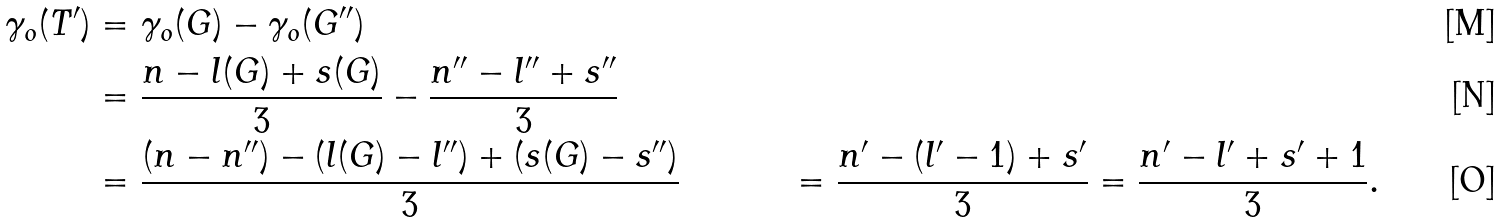Convert formula to latex. <formula><loc_0><loc_0><loc_500><loc_500>\gamma _ { o } ( T ^ { \prime } ) & = \gamma _ { o } ( G ) - \gamma _ { o } ( G ^ { \prime \prime } ) \\ & = \frac { n - l ( G ) + s ( G ) } { 3 } - \frac { n ^ { \prime \prime } - l ^ { \prime \prime } + s ^ { \prime \prime } } { 3 } \\ & = \frac { ( n - n ^ { \prime \prime } ) - ( l ( G ) - l ^ { \prime \prime } ) + ( s ( G ) - s ^ { \prime \prime } ) } { 3 } & = \frac { n ^ { \prime } - ( l ^ { \prime } - 1 ) + s ^ { \prime } } { 3 } = \frac { n ^ { \prime } - l ^ { \prime } + s ^ { \prime } + 1 } { 3 } .</formula> 